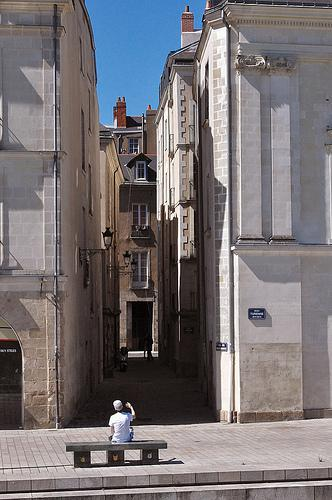Question: when was this photo taken?
Choices:
A. Nightime.
B. Afternoon.
C. Daytime.
D. Evening.
Answer with the letter. Answer: C Question: why is the alley dark?
Choices:
A. No street light.
B. Light broke.
C. Building shadow.
D. It is not used.
Answer with the letter. Answer: C Question: what is the bench made of?
Choices:
A. Stone.
B. Wood.
C. Plastic.
D. Metal.
Answer with the letter. Answer: A Question: what color are the buildings?
Choices:
A. Tan.
B. Cream.
C. Gray.
D. Beige.
Answer with the letter. Answer: D 